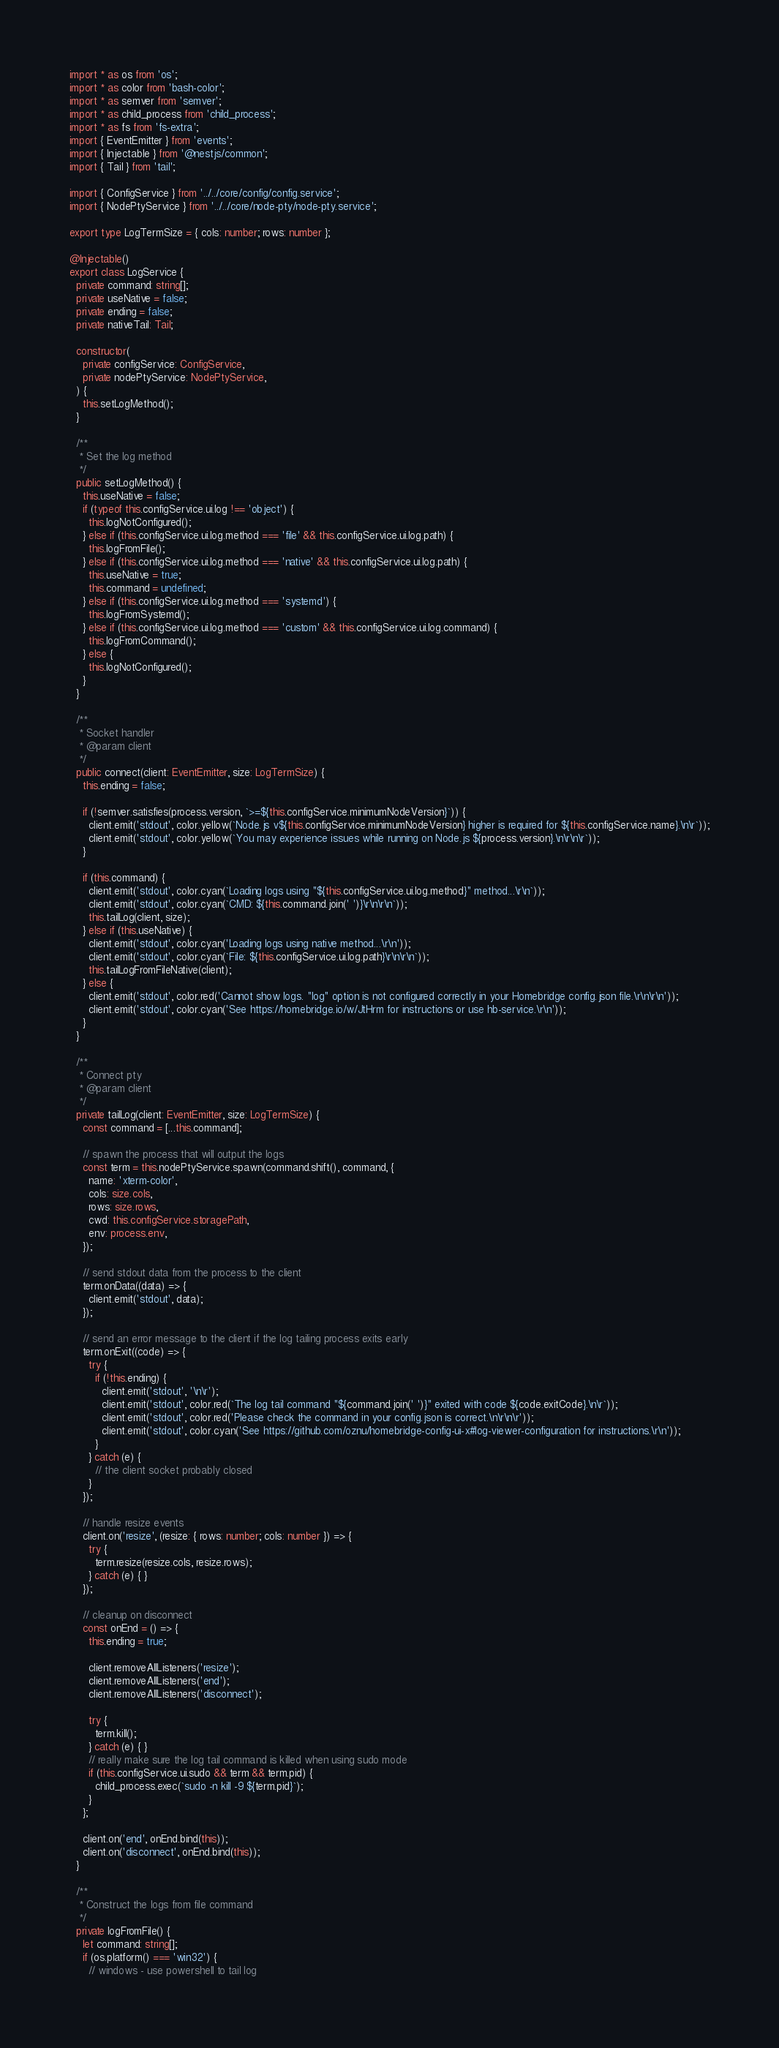<code> <loc_0><loc_0><loc_500><loc_500><_TypeScript_>import * as os from 'os';
import * as color from 'bash-color';
import * as semver from 'semver';
import * as child_process from 'child_process';
import * as fs from 'fs-extra';
import { EventEmitter } from 'events';
import { Injectable } from '@nestjs/common';
import { Tail } from 'tail';

import { ConfigService } from '../../core/config/config.service';
import { NodePtyService } from '../../core/node-pty/node-pty.service';

export type LogTermSize = { cols: number; rows: number };

@Injectable()
export class LogService {
  private command: string[];
  private useNative = false;
  private ending = false;
  private nativeTail: Tail;

  constructor(
    private configService: ConfigService,
    private nodePtyService: NodePtyService,
  ) {
    this.setLogMethod();
  }

  /**
   * Set the log method
   */
  public setLogMethod() {
    this.useNative = false;
    if (typeof this.configService.ui.log !== 'object') {
      this.logNotConfigured();
    } else if (this.configService.ui.log.method === 'file' && this.configService.ui.log.path) {
      this.logFromFile();
    } else if (this.configService.ui.log.method === 'native' && this.configService.ui.log.path) {
      this.useNative = true;
      this.command = undefined;
    } else if (this.configService.ui.log.method === 'systemd') {
      this.logFromSystemd();
    } else if (this.configService.ui.log.method === 'custom' && this.configService.ui.log.command) {
      this.logFromCommand();
    } else {
      this.logNotConfigured();
    }
  }

  /**
   * Socket handler
   * @param client
   */
  public connect(client: EventEmitter, size: LogTermSize) {
    this.ending = false;

    if (!semver.satisfies(process.version, `>=${this.configService.minimumNodeVersion}`)) {
      client.emit('stdout', color.yellow(`Node.js v${this.configService.minimumNodeVersion} higher is required for ${this.configService.name}.\n\r`));
      client.emit('stdout', color.yellow(`You may experience issues while running on Node.js ${process.version}.\n\r\n\r`));
    }

    if (this.command) {
      client.emit('stdout', color.cyan(`Loading logs using "${this.configService.ui.log.method}" method...\r\n`));
      client.emit('stdout', color.cyan(`CMD: ${this.command.join(' ')}\r\n\r\n`));
      this.tailLog(client, size);
    } else if (this.useNative) {
      client.emit('stdout', color.cyan('Loading logs using native method...\r\n'));
      client.emit('stdout', color.cyan(`File: ${this.configService.ui.log.path}\r\n\r\n`));
      this.tailLogFromFileNative(client);
    } else {
      client.emit('stdout', color.red('Cannot show logs. "log" option is not configured correctly in your Homebridge config.json file.\r\n\r\n'));
      client.emit('stdout', color.cyan('See https://homebridge.io/w/JtHrm for instructions or use hb-service.\r\n'));
    }
  }

  /**
   * Connect pty
   * @param client
   */
  private tailLog(client: EventEmitter, size: LogTermSize) {
    const command = [...this.command];

    // spawn the process that will output the logs
    const term = this.nodePtyService.spawn(command.shift(), command, {
      name: 'xterm-color',
      cols: size.cols,
      rows: size.rows,
      cwd: this.configService.storagePath,
      env: process.env,
    });

    // send stdout data from the process to the client
    term.onData((data) => {
      client.emit('stdout', data);
    });

    // send an error message to the client if the log tailing process exits early
    term.onExit((code) => {
      try {
        if (!this.ending) {
          client.emit('stdout', '\n\r');
          client.emit('stdout', color.red(`The log tail command "${command.join(' ')}" exited with code ${code.exitCode}.\n\r`));
          client.emit('stdout', color.red('Please check the command in your config.json is correct.\n\r\n\r'));
          client.emit('stdout', color.cyan('See https://github.com/oznu/homebridge-config-ui-x#log-viewer-configuration for instructions.\r\n'));
        }
      } catch (e) {
        // the client socket probably closed
      }
    });

    // handle resize events
    client.on('resize', (resize: { rows: number; cols: number }) => {
      try {
        term.resize(resize.cols, resize.rows);
      } catch (e) { }
    });

    // cleanup on disconnect
    const onEnd = () => {
      this.ending = true;

      client.removeAllListeners('resize');
      client.removeAllListeners('end');
      client.removeAllListeners('disconnect');

      try {
        term.kill();
      } catch (e) { }
      // really make sure the log tail command is killed when using sudo mode
      if (this.configService.ui.sudo && term && term.pid) {
        child_process.exec(`sudo -n kill -9 ${term.pid}`);
      }
    };

    client.on('end', onEnd.bind(this));
    client.on('disconnect', onEnd.bind(this));
  }

  /**
   * Construct the logs from file command
   */
  private logFromFile() {
    let command: string[];
    if (os.platform() === 'win32') {
      // windows - use powershell to tail log</code> 